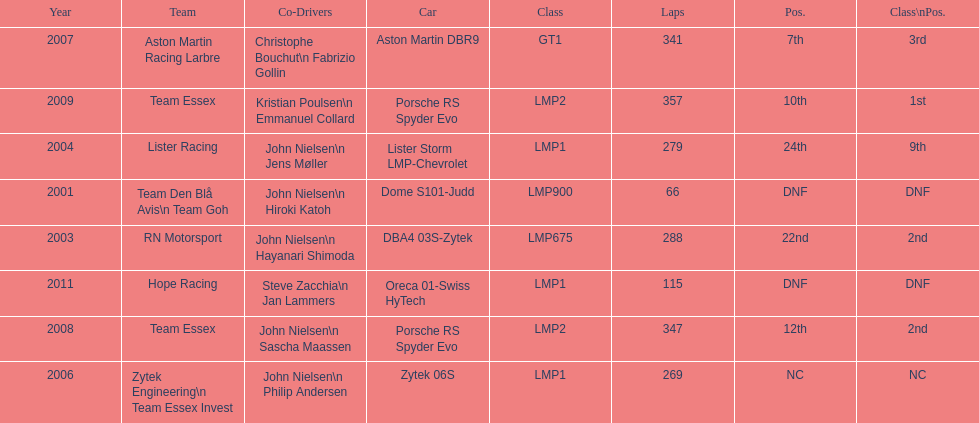In 2008 and what other year was casper elgaard on team essex for the 24 hours of le mans? 2009. 